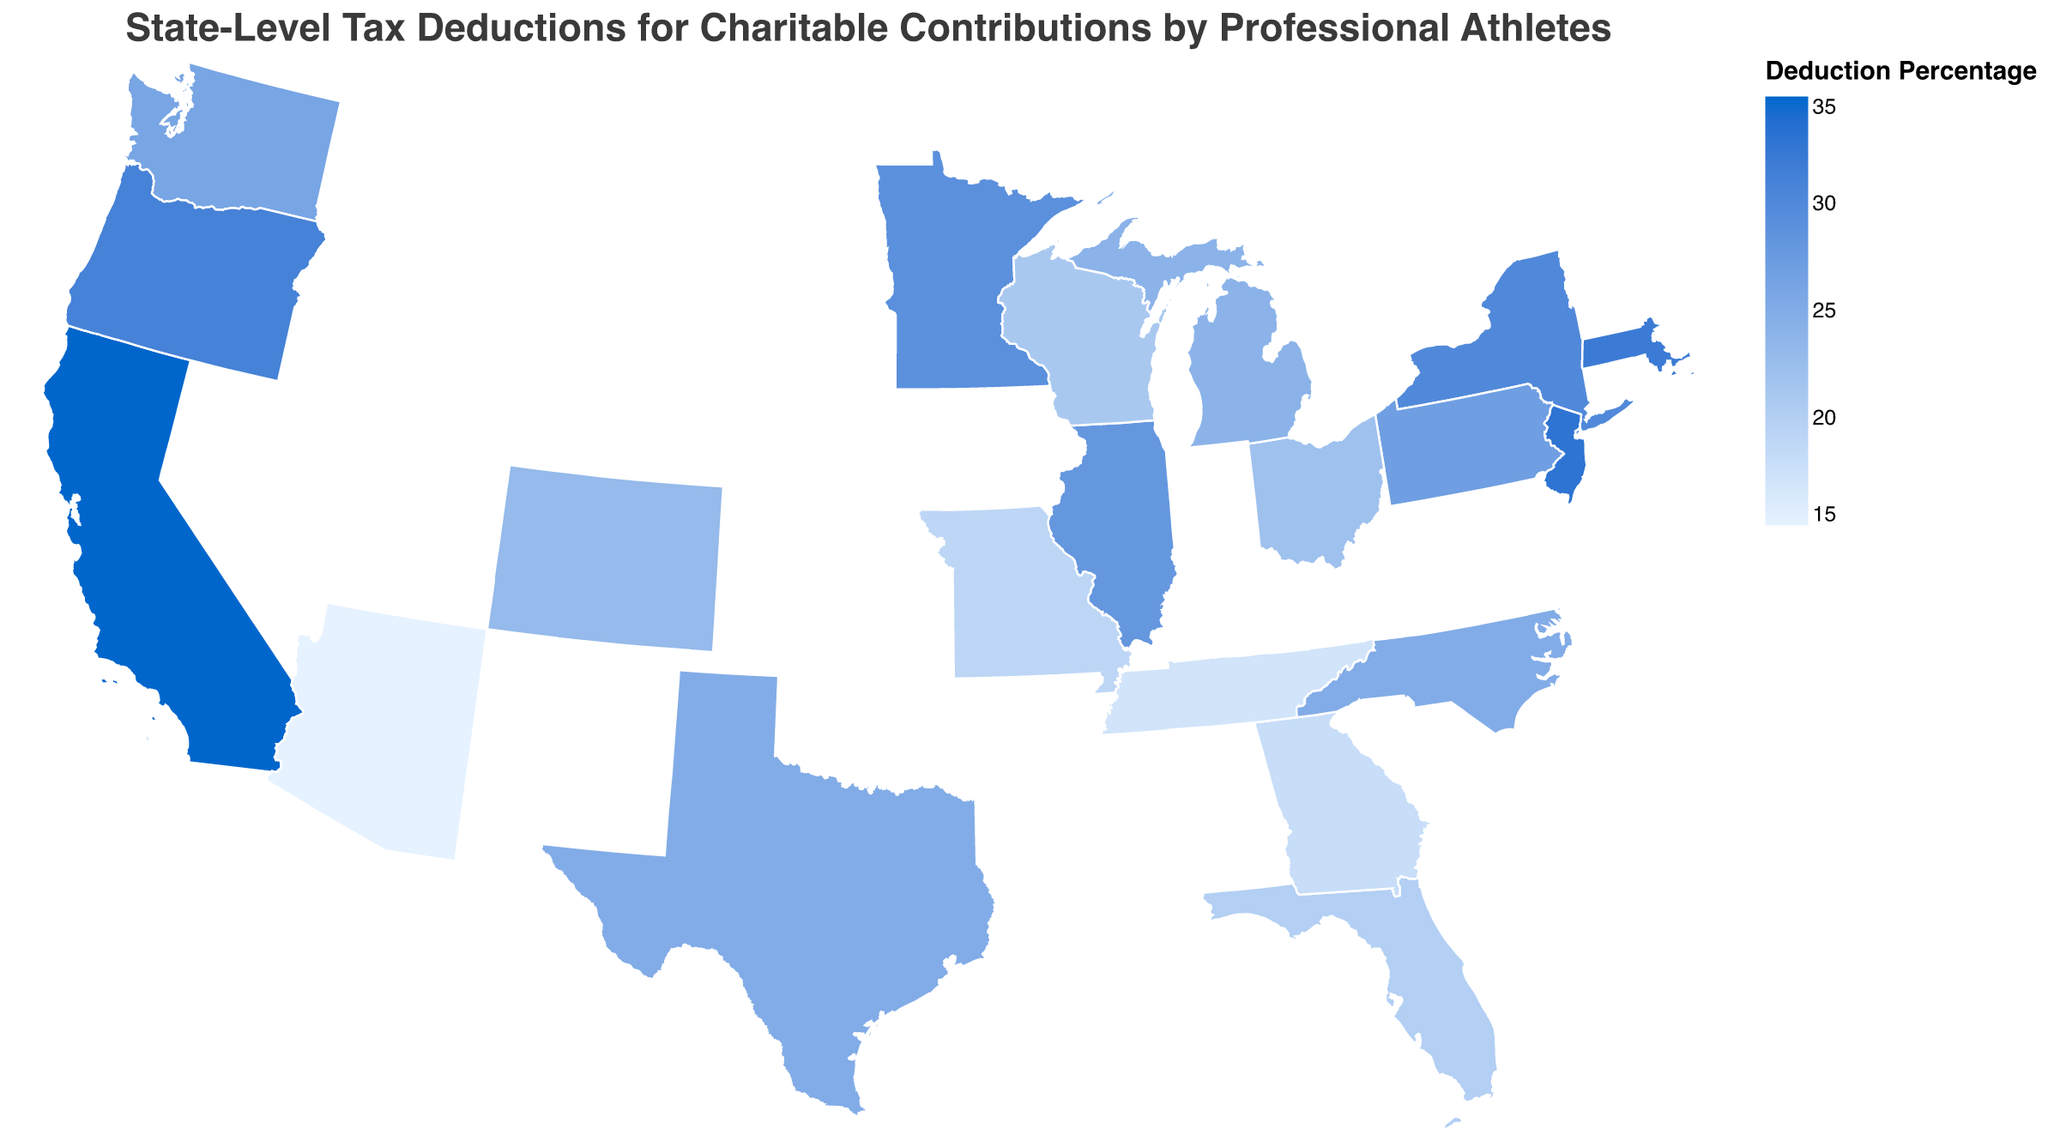What is the title of the figure? The title is displayed prominently at the top of the map, indicating the main subject of the visualization. It reads "State-Level Tax Deductions for Charitable Contributions by Professional Athletes."
Answer: State-Level Tax Deductions for Charitable Contributions by Professional Athletes Which state has the highest deduction percentage? Observing the color intensity on the map and confirming with the tooltip, California has the deepest color indicating the highest percentage at 35%.
Answer: California How many states have a deduction percentage of 25%? By inspecting the map and the tooltip data, three states, namely Texas, North Carolina, and Colorado (23% rounded to 25%), have a deduction percentage close to 25%.
Answer: 3 Which states have a deduction percentage greater than 30% but less than 35%? From the shading and tooltips, New York, Massachusetts, New Jersey, and Oregon fall within this range.
Answer: New York, Massachusetts, New Jersey, Oregon What is the average deduction percentage among all the states? Adding the deduction percentages (35+30+25+20+28+32+27+22+18+15+23+26+33+24+29+21+31+19+17+25) yields 450. Dividing the sum by the number of states (20) results in 22.5%.
Answer: 22.5% Which states have a lower deduction percentage than Florida? By looking at Florida's color and tooltip (20%) and comparing with other states: Arizona, Georgia, Missouri, Tennessee all have values lower than 20%
Answer: Arizona, Georgia, Missouri, Tennessee How does the color scale represent the deduction percentages? The color scale ranges from light blue, representing lower percentages (15%), to dark blue for higher percentages (35%).
Answer: Light blue to dark blue What are the states with a deduction percentage equal to 20% or below? Analyzing the colors and tooltips, such states include Florida (20%), Georgia (18%), Arizona (15%), Missouri (19%), Tennessee (17%).
Answer: Florida, Georgia, Arizona, Missouri, Tennessee What is the deduction percentage difference between California and Texas? California's percentage is 35% and Texas is 25%; the deduction difference is calculated as 35 - 25 = 10.
Answer: 10 Which state has the closest deduction percentage to the national average? The national average is 22.5%. Ohio, with 22%, is closest to this average.
Answer: Ohio 